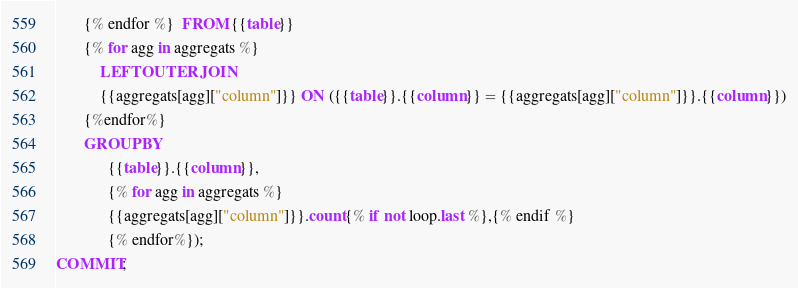Convert code to text. <code><loc_0><loc_0><loc_500><loc_500><_SQL_>       {% endfor %}  FROM {{table}}
       {% for agg in aggregats %}
           LEFT OUTER JOIN
           {{aggregats[agg]["column"]}} ON ({{table}}.{{column}} = {{aggregats[agg]["column"]}}.{{column}})
       {%endfor%}
       GROUP BY
             {{table}}.{{column}},
             {% for agg in aggregats %}
             {{aggregats[agg]["column"]}}.count{% if not loop.last %},{% endif %}
             {% endfor%});
COMMIT;
</code> 